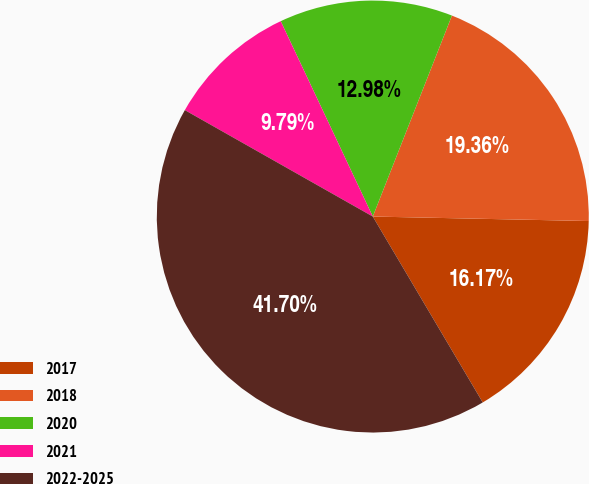Convert chart. <chart><loc_0><loc_0><loc_500><loc_500><pie_chart><fcel>2017<fcel>2018<fcel>2020<fcel>2021<fcel>2022-2025<nl><fcel>16.17%<fcel>19.36%<fcel>12.98%<fcel>9.79%<fcel>41.7%<nl></chart> 